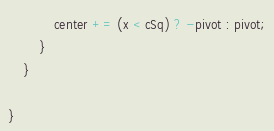Convert code to text. <code><loc_0><loc_0><loc_500><loc_500><_Java_>            center += (x < cSq) ? -pivot : pivot;
        }
    }

}
</code> 